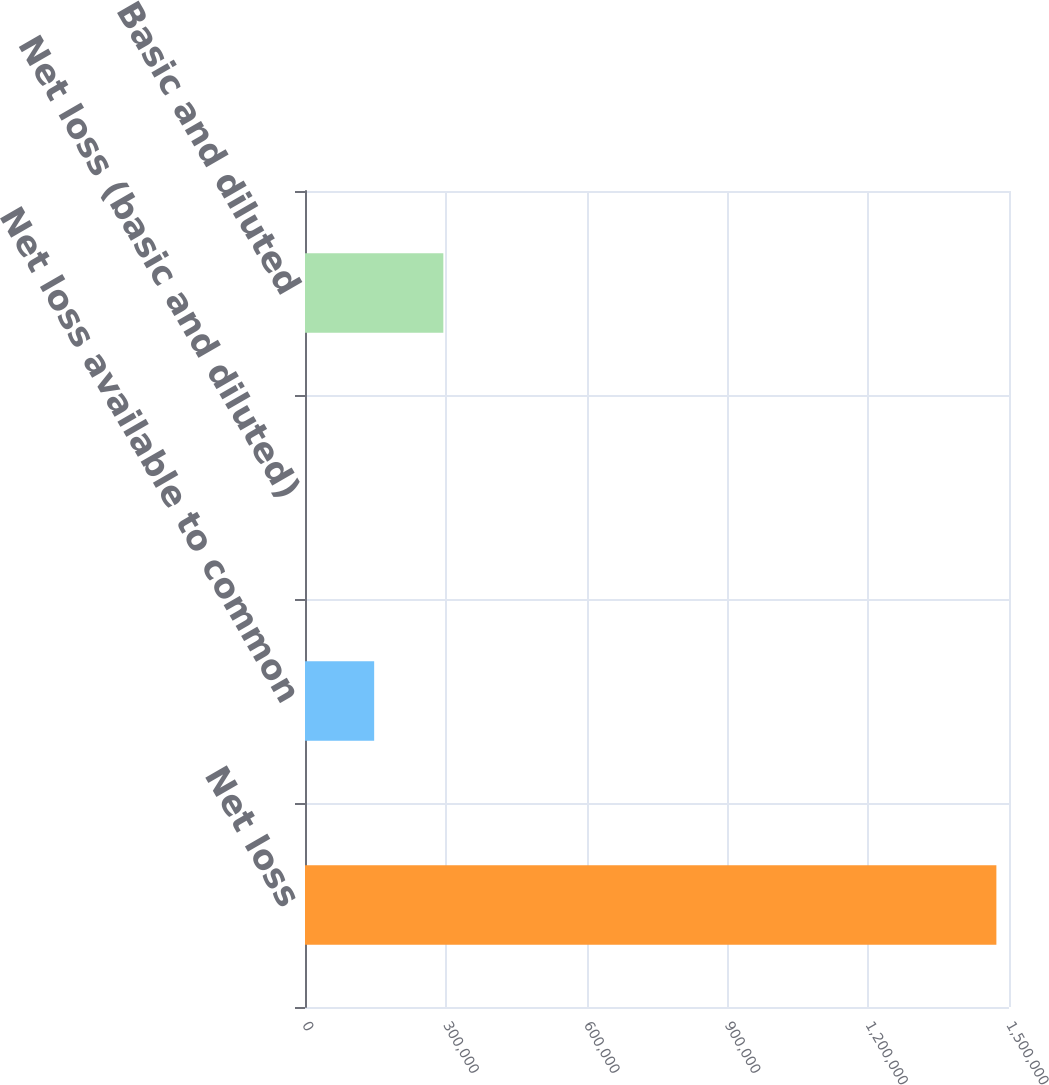Convert chart. <chart><loc_0><loc_0><loc_500><loc_500><bar_chart><fcel>Net loss<fcel>Net loss available to common<fcel>Net loss (basic and diluted)<fcel>Basic and diluted<nl><fcel>1.47311e+06<fcel>147379<fcel>5.81<fcel>294753<nl></chart> 